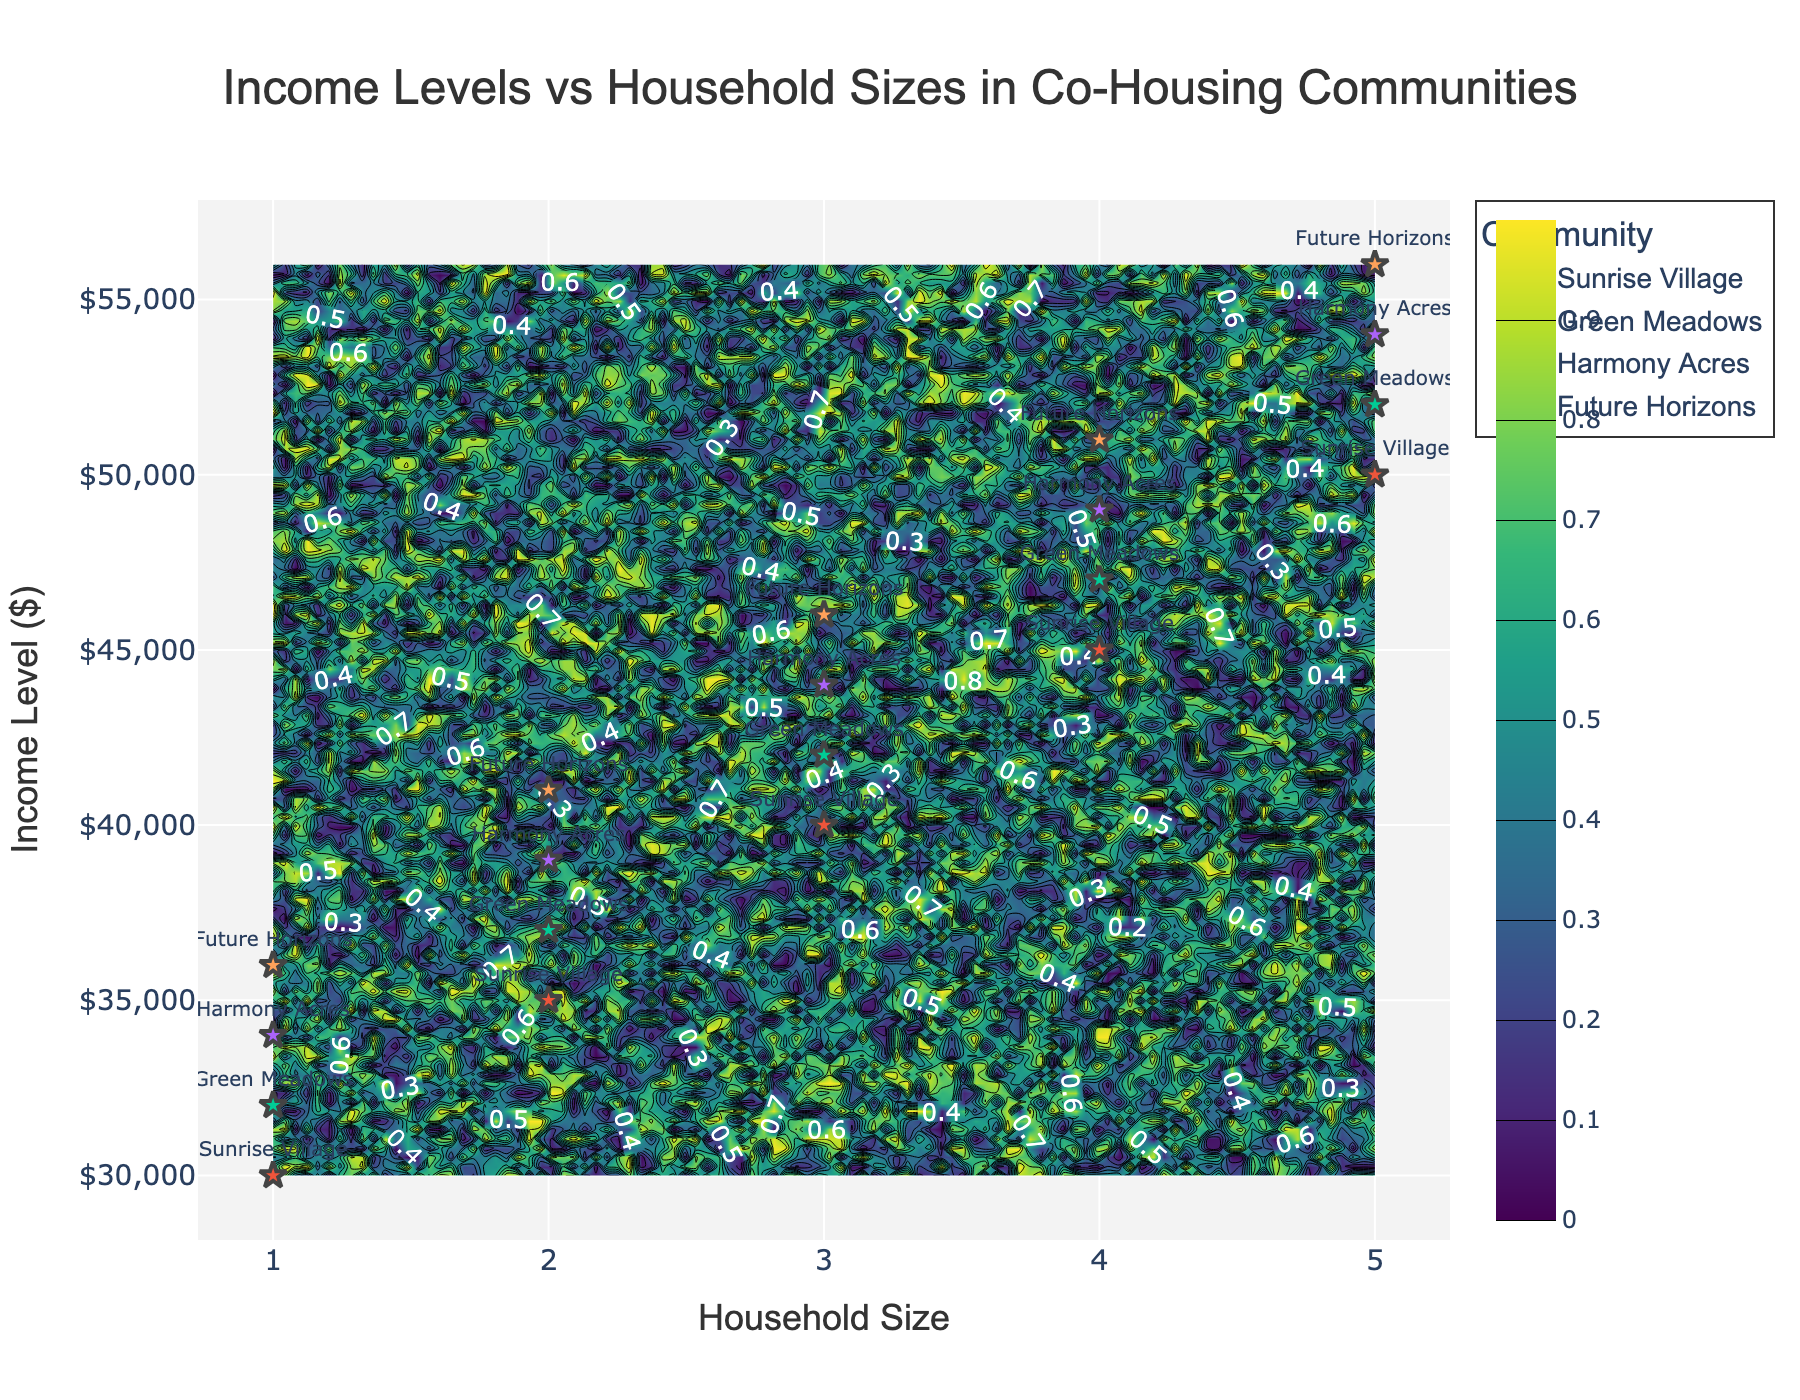What is the title of the plot? The title is displayed at the top center of the plot. It reads "Income Levels vs Household Sizes in Co-Housing Communities."
Answer: Income Levels vs Household Sizes in Co-Housing Communities What is the range of the household sizes represented on the x-axis? By looking at the x-axis, the household sizes range from 1 to 5.
Answer: 1 to 5 Which community has the highest income level for a household size of 5? Check the markers for household size 5 and identify the community with the highest income level, which appears on the y-axis. Future Horizons has the highest at $56,000.
Answer: Future Horizons At a household size of 3, which community has the lowest income level? Look at the markers for household size 3 and determine which community has the lowest income level on the y-axis. Sunrise Village has the lowest at $40,000.
Answer: Sunrise Village What household size in Green Meadows has an income level of $42,000? Locate the marker for the Green Meadows community and check which household size corresponds to the income level of $42,000. It corresponds to a household size of 3.
Answer: 3 Do communities have the same or varying income levels for the same household sizes? Compare the markers across different communities for each household size to see if the income levels differ. The income levels vary among communities for the same household sizes.
Answer: Varying How many communities are represented in the plot? Count the number of unique community names used as labels. There are four communities represented: Sunrise Village, Green Meadows, Harmony Acres, and Future Horizons.
Answer: Four What is the overall trend between household size and income level? By examining how income levels change with household sizes, there is a general upward trend indicating that larger household sizes tend to have higher income levels.
Answer: Upward trend Between Sunrise Village and Harmony Acres, which community has a higher income for a household size of 4? Compare the income levels for both communities at a household size of 4. Harmony Acres has a higher income of $49,000 compared to Sunrise Village's $45,000.
Answer: Harmony Acres Which household size in Future Horizons has the lowest income level, and what is that income? Identify the markers for Future Horizons and find the household size with the lowest income. It is household size 1 with an income of $36,000.
Answer: Size 1 and $36,000 